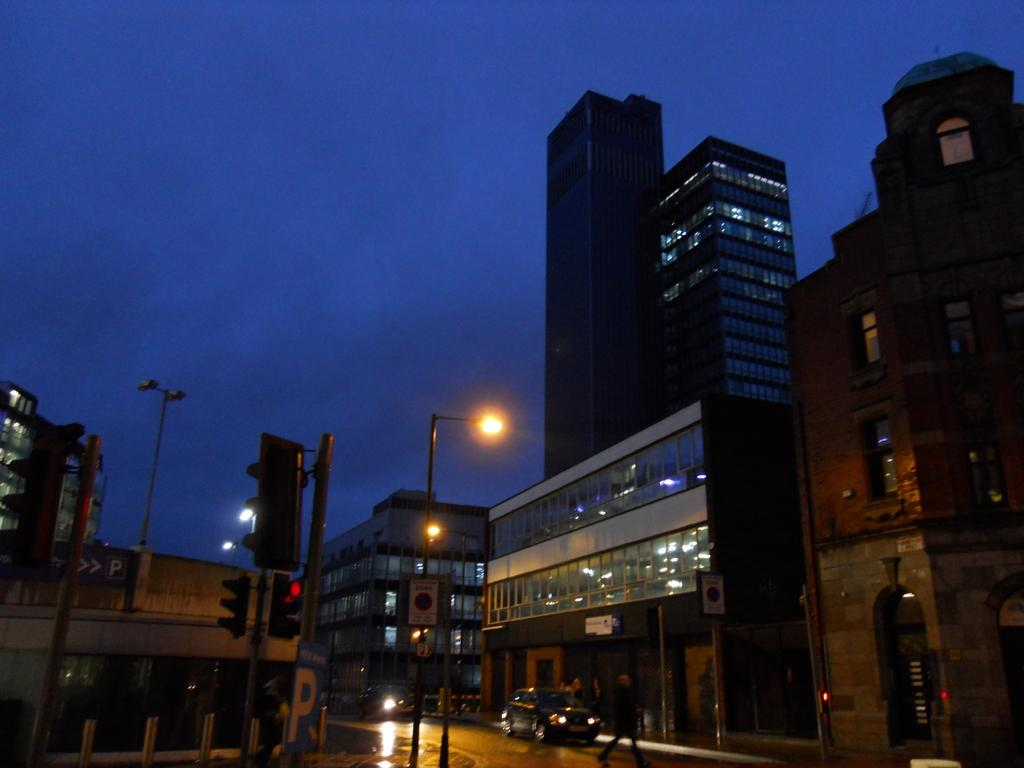What type of structures are present in the image? There are skyscrapers and buildings in the image. What can be seen on the streets in the image? Traffic poles, traffic signals, motor vehicles, sign boards, street poles, and street lights are visible on the streets in the image. Are there any people present in the image? Yes, there is a person on the road in the image. What type of board is the rabbit riding on in the image? There is no rabbit or board present in the image. What is the person on the road doing with their mouth in the image? The person's mouth is not visible in the image, and their actions are not described. 